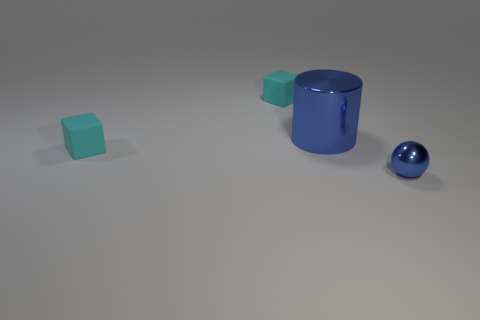Add 4 yellow matte balls. How many objects exist? 8 Subtract all blue blocks. Subtract all purple spheres. How many blocks are left? 2 Subtract all brown cylinders. How many purple cubes are left? 0 Subtract all big cyan metal things. Subtract all large metal things. How many objects are left? 3 Add 1 large shiny objects. How many large shiny objects are left? 2 Add 4 rubber objects. How many rubber objects exist? 6 Subtract 0 blue blocks. How many objects are left? 4 Subtract all cylinders. How many objects are left? 3 Subtract 1 cylinders. How many cylinders are left? 0 